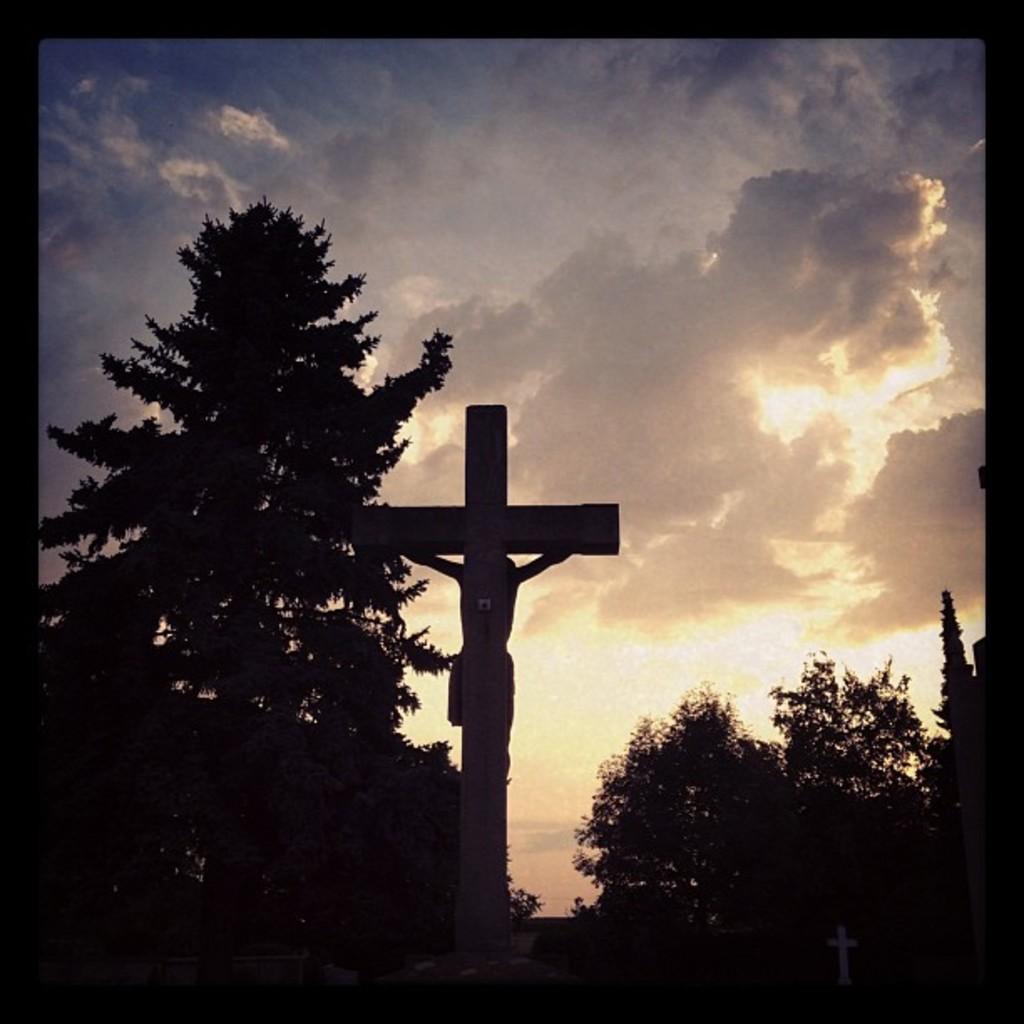How would you summarize this image in a sentence or two? In this image there are trees. There is statue of Jesus Christ. There are clouds in the sky. 